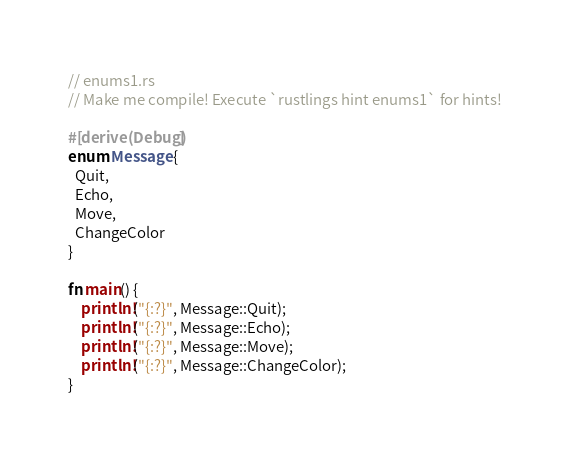<code> <loc_0><loc_0><loc_500><loc_500><_Rust_>// enums1.rs
// Make me compile! Execute `rustlings hint enums1` for hints!

#[derive(Debug)]
enum Message {
  Quit,
  Echo,
  Move,
  ChangeColor
}

fn main() {
    println!("{:?}", Message::Quit);
    println!("{:?}", Message::Echo);
    println!("{:?}", Message::Move);
    println!("{:?}", Message::ChangeColor);
}
</code> 